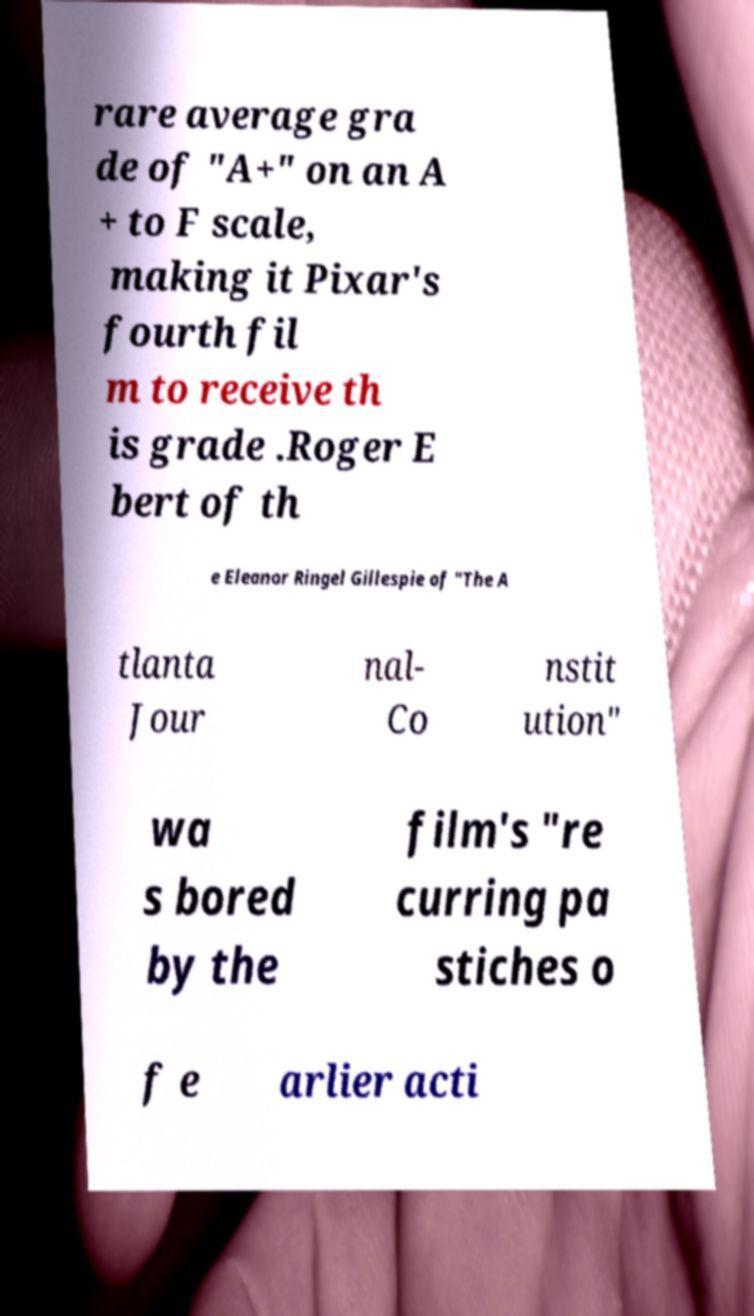Can you read and provide the text displayed in the image?This photo seems to have some interesting text. Can you extract and type it out for me? rare average gra de of "A+" on an A + to F scale, making it Pixar's fourth fil m to receive th is grade .Roger E bert of th e Eleanor Ringel Gillespie of "The A tlanta Jour nal- Co nstit ution" wa s bored by the film's "re curring pa stiches o f e arlier acti 